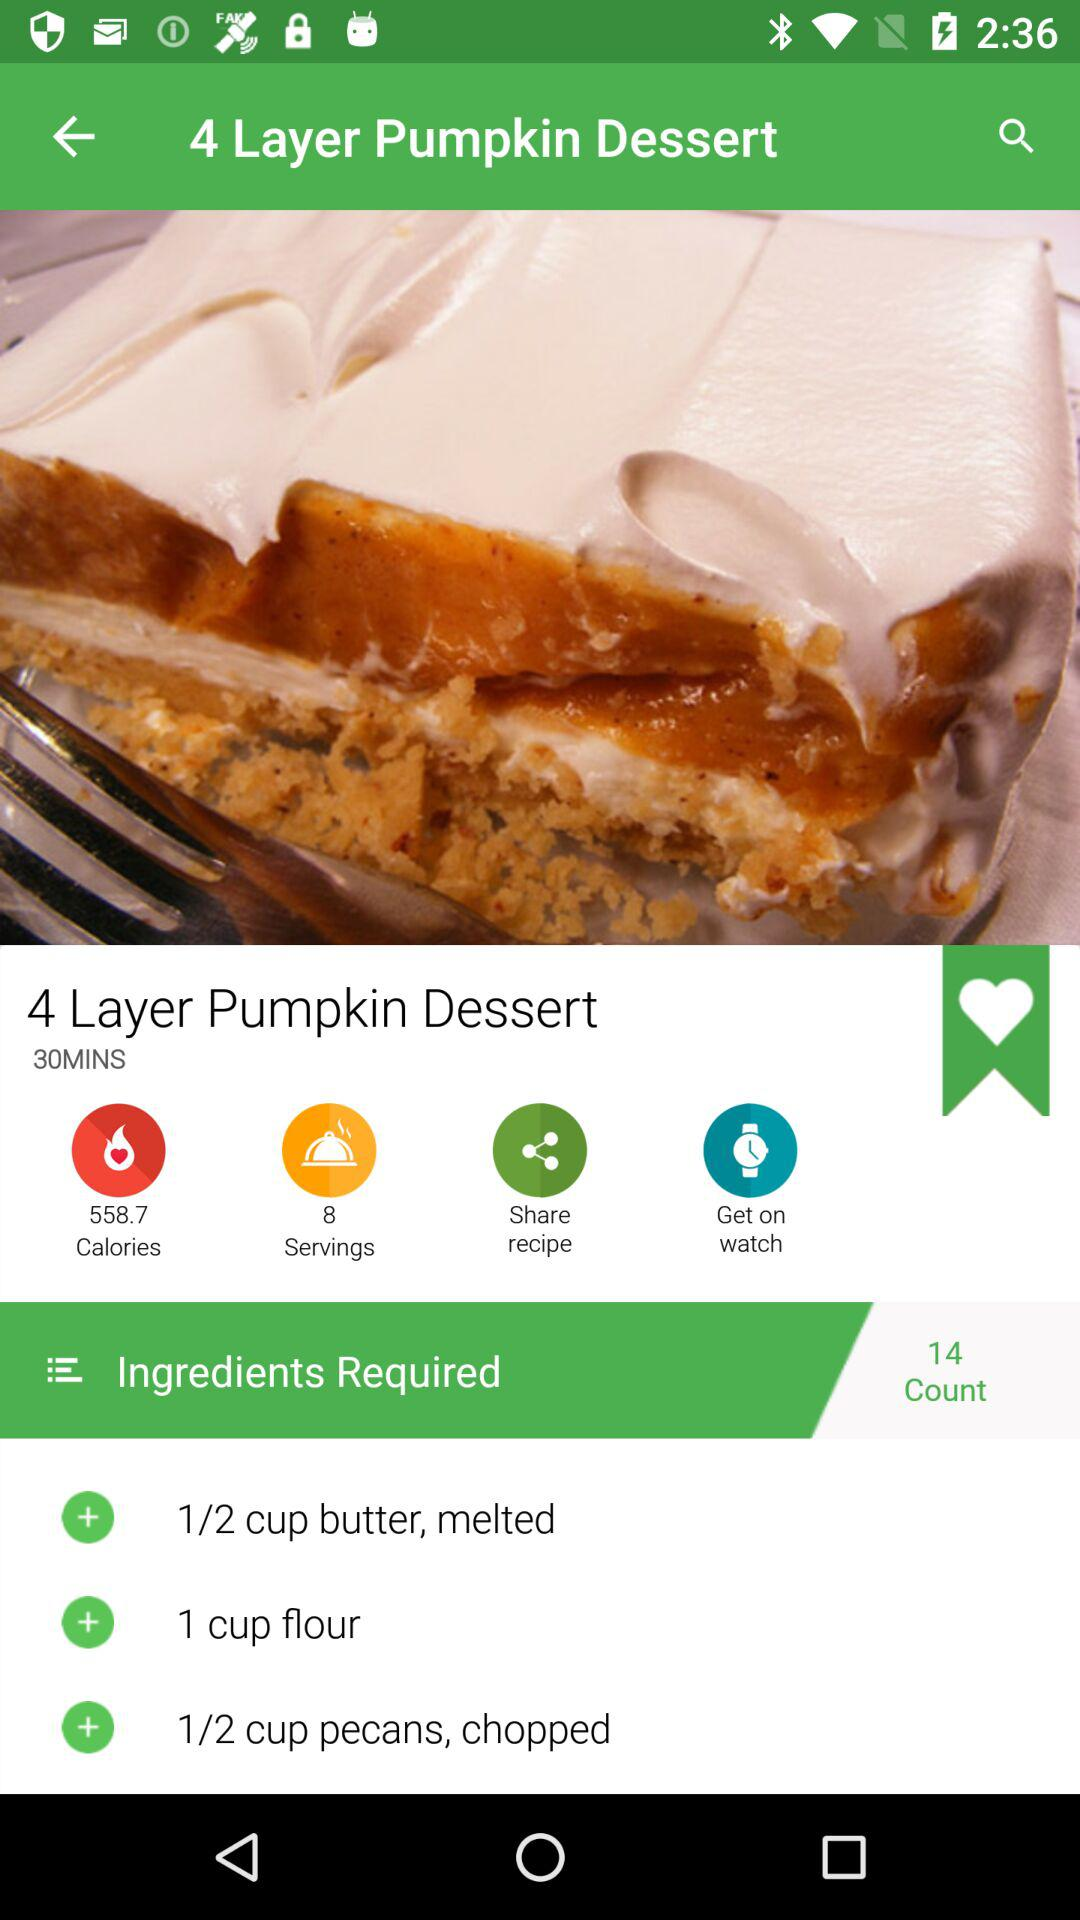How many minutes is this recipe?
Answer the question using a single word or phrase. 30 